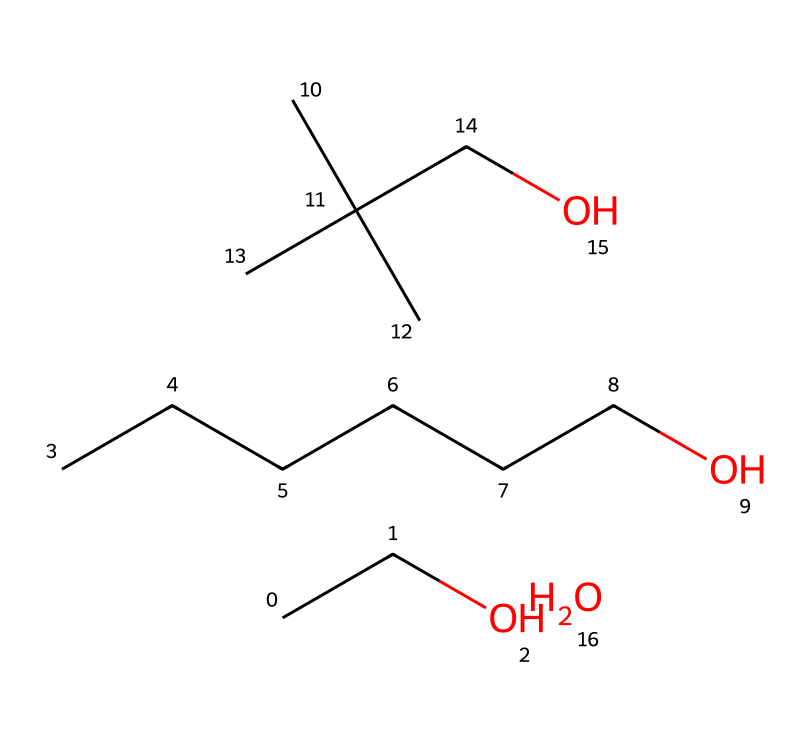What is the main functional group present in this chemical? The SMILES representation indicates the presence of an alcohol group, discernible from the 'O' connected to a carbon chain. This structure contains an -OH group, which is characteristic of alcohols.
Answer: alcohol How many carbon atoms are present in the molecule? By analyzing the SMILES, each 'C' represents a carbon atom, and there are a total of 8 carbon atoms when counted sequentially in the representation.
Answer: 8 What type of bond is primarily present in this chemical structure? In organic compounds like this one, the bonds between carbon and other atoms (C-C and C-O) are mostly single covalent bonds. The absence of double or triple bonds reflects its nature as a flammable liquid.
Answer: single bonds What is the expected boiling point range for this chemical? Given the mixture of long and short carbon chains and the presence of an alcohol group, similar chemicals typically have a boiling point around 60 to 85 degrees Celsius, which is characteristic for many ethanol-based solutions.
Answer: 60 to 85 degrees Celsius How does the presence of the alcohol group affect the flammability of this substance? Alcohol groups typically indicate that the substance can evaporate easily and catch fire when exposed to an ignitable source, increasing the flammability of the chemical due to its lower flash point.
Answer: increases flammability What part of the chemical structure influences its solubility in water? The alcohol (-OH) group is highly polar, leading to strong hydrogen bonding with water molecules. This polarity enhances the solubility of the chemical in water, which is essential for hand sanitizers.
Answer: -OH group 